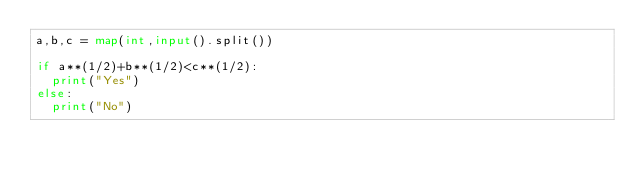Convert code to text. <code><loc_0><loc_0><loc_500><loc_500><_Python_>a,b,c = map(int,input().split())

if a**(1/2)+b**(1/2)<c**(1/2):
  print("Yes")
else:
  print("No")</code> 